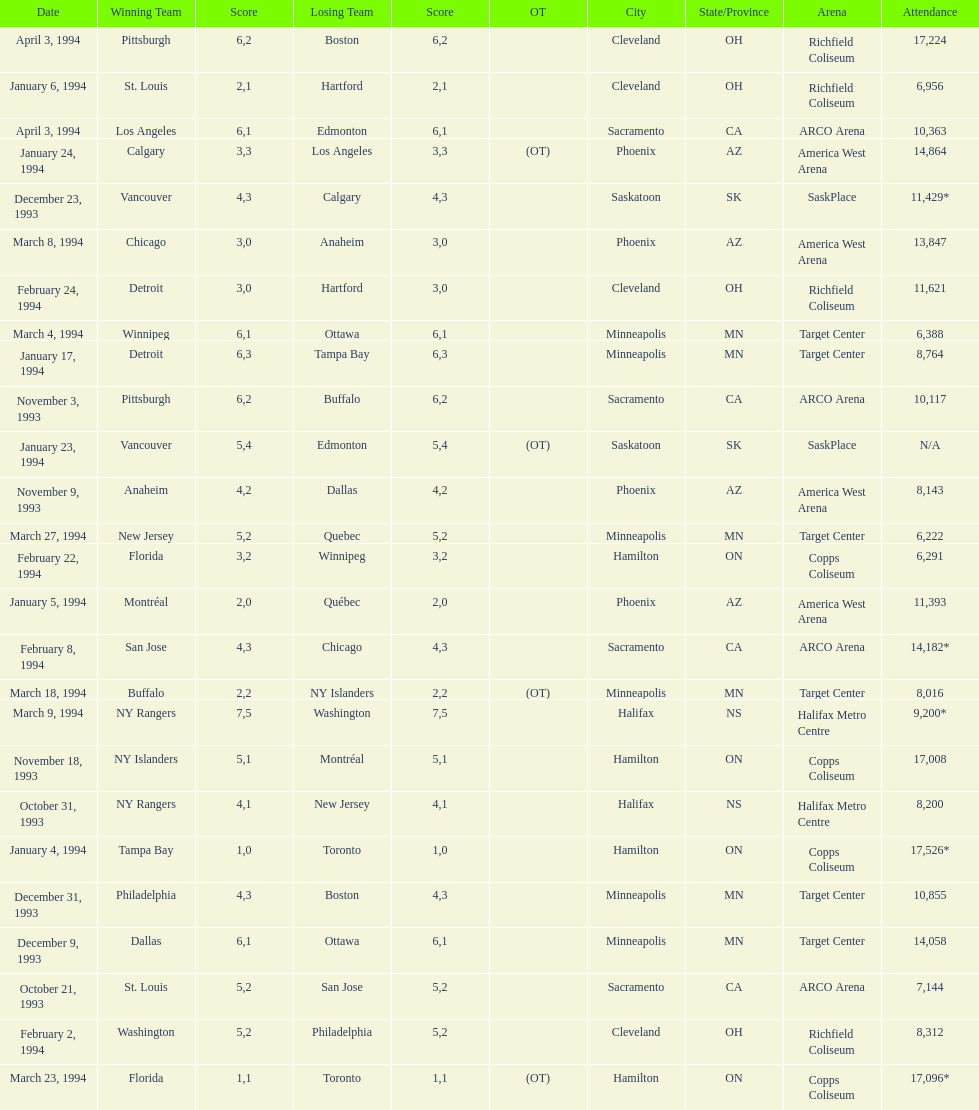Could you parse the entire table? {'header': ['Date', 'Winning Team', 'Score', 'Losing Team', 'Score', 'OT', 'City', 'State/Province', 'Arena', 'Attendance'], 'rows': [['April 3, 1994', 'Pittsburgh', '6', 'Boston', '2', '', 'Cleveland', 'OH', 'Richfield Coliseum', '17,224'], ['January 6, 1994', 'St. Louis', '2', 'Hartford', '1', '', 'Cleveland', 'OH', 'Richfield Coliseum', '6,956'], ['April 3, 1994', 'Los Angeles', '6', 'Edmonton', '1', '', 'Sacramento', 'CA', 'ARCO Arena', '10,363'], ['January 24, 1994', 'Calgary', '3', 'Los Angeles', '3', '(OT)', 'Phoenix', 'AZ', 'America West Arena', '14,864'], ['December 23, 1993', 'Vancouver', '4', 'Calgary', '3', '', 'Saskatoon', 'SK', 'SaskPlace', '11,429*'], ['March 8, 1994', 'Chicago', '3', 'Anaheim', '0', '', 'Phoenix', 'AZ', 'America West Arena', '13,847'], ['February 24, 1994', 'Detroit', '3', 'Hartford', '0', '', 'Cleveland', 'OH', 'Richfield Coliseum', '11,621'], ['March 4, 1994', 'Winnipeg', '6', 'Ottawa', '1', '', 'Minneapolis', 'MN', 'Target Center', '6,388'], ['January 17, 1994', 'Detroit', '6', 'Tampa Bay', '3', '', 'Minneapolis', 'MN', 'Target Center', '8,764'], ['November 3, 1993', 'Pittsburgh', '6', 'Buffalo', '2', '', 'Sacramento', 'CA', 'ARCO Arena', '10,117'], ['January 23, 1994', 'Vancouver', '5', 'Edmonton', '4', '(OT)', 'Saskatoon', 'SK', 'SaskPlace', 'N/A'], ['November 9, 1993', 'Anaheim', '4', 'Dallas', '2', '', 'Phoenix', 'AZ', 'America West Arena', '8,143'], ['March 27, 1994', 'New Jersey', '5', 'Quebec', '2', '', 'Minneapolis', 'MN', 'Target Center', '6,222'], ['February 22, 1994', 'Florida', '3', 'Winnipeg', '2', '', 'Hamilton', 'ON', 'Copps Coliseum', '6,291'], ['January 5, 1994', 'Montréal', '2', 'Québec', '0', '', 'Phoenix', 'AZ', 'America West Arena', '11,393'], ['February 8, 1994', 'San Jose', '4', 'Chicago', '3', '', 'Sacramento', 'CA', 'ARCO Arena', '14,182*'], ['March 18, 1994', 'Buffalo', '2', 'NY Islanders', '2', '(OT)', 'Minneapolis', 'MN', 'Target Center', '8,016'], ['March 9, 1994', 'NY Rangers', '7', 'Washington', '5', '', 'Halifax', 'NS', 'Halifax Metro Centre', '9,200*'], ['November 18, 1993', 'NY Islanders', '5', 'Montréal', '1', '', 'Hamilton', 'ON', 'Copps Coliseum', '17,008'], ['October 31, 1993', 'NY Rangers', '4', 'New Jersey', '1', '', 'Halifax', 'NS', 'Halifax Metro Centre', '8,200'], ['January 4, 1994', 'Tampa Bay', '1', 'Toronto', '0', '', 'Hamilton', 'ON', 'Copps Coliseum', '17,526*'], ['December 31, 1993', 'Philadelphia', '4', 'Boston', '3', '', 'Minneapolis', 'MN', 'Target Center', '10,855'], ['December 9, 1993', 'Dallas', '6', 'Ottawa', '1', '', 'Minneapolis', 'MN', 'Target Center', '14,058'], ['October 21, 1993', 'St. Louis', '5', 'San Jose', '2', '', 'Sacramento', 'CA', 'ARCO Arena', '7,144'], ['February 2, 1994', 'Washington', '5', 'Philadelphia', '2', '', 'Cleveland', 'OH', 'Richfield Coliseum', '8,312'], ['March 23, 1994', 'Florida', '1', 'Toronto', '1', '(OT)', 'Hamilton', 'ON', 'Copps Coliseum', '17,096*']]} The game on which date had the most attendance? January 4, 1994. 